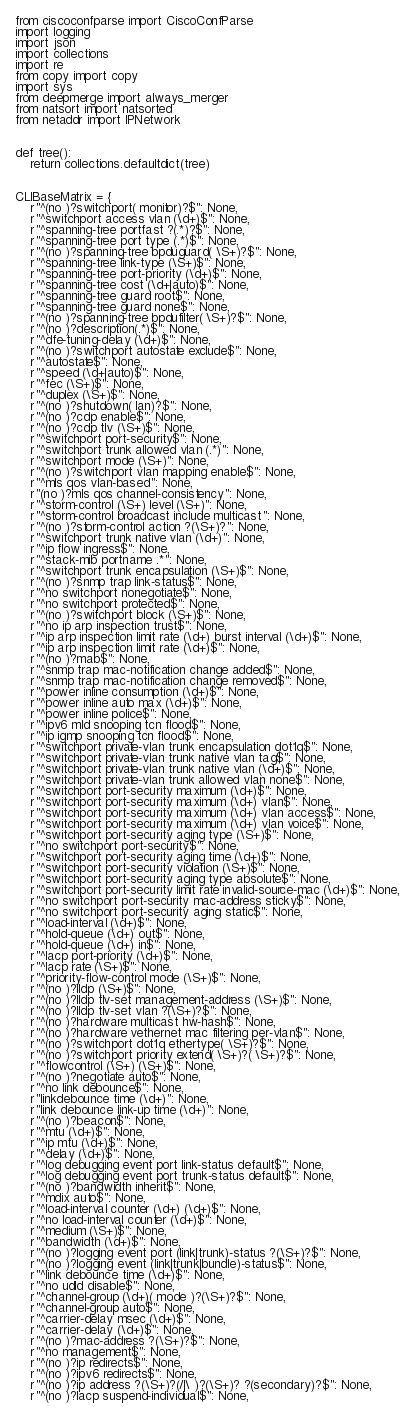Convert code to text. <code><loc_0><loc_0><loc_500><loc_500><_Python_>from ciscoconfparse import CiscoConfParse
import logging
import json
import collections
import re
from copy import copy
import sys
from deepmerge import always_merger
from natsort import natsorted
from netaddr import IPNetwork


def tree():
    return collections.defaultdict(tree)


CLIBaseMatrix = {
    r"^(no )?switchport( monitor)?$": None,
    r"^switchport access vlan (\d+)$": None,
    r"^spanning-tree portfast ?(.*)?$": None,
    r"^spanning-tree port type (.*)$": None,
    r"^(no )?spanning-tree bpduguard( \S+)?$": None,
    r"^spanning-tree link-type (\S+)$": None,
    r"^spanning-tree port-priority (\d+)$": None,
    r"^spanning-tree cost (\d+|auto)$": None,
    r"^spanning-tree guard root$": None,
    r"^spanning-tree guard none$": None,
    r"^(no )?spanning-tree bpdufilter( \S+)?$": None,
    r"^(no )?description(.*)$": None,
    r"^dfe-tuning-delay (\d+)$": None,
    r"^(no )?switchport autostate exclude$": None,
    r"^autostate$": None,
    r"^speed (\d+|auto)$": None,
    r"^fec (\S+)$": None,
    r"^duplex (\S+)$": None,
    r"^(no )?shutdown( lan)?$": None,
    r"^(no )?cdp enable$": None,
    r"^(no )?cdp tlv (\S+)$": None,
    r"^switchport port-security$": None,
    r"^switchport trunk allowed vlan (.*)": None,
    r"^switchport mode (\S+)": None,
    r"^(no )?switchport vlan mapping enable$": None,
    r"^mls qos vlan-based": None,
    r"(no )?mls qos channel-consistency": None,
    r"^storm-control (\S+) level (\S+)": None,
    r"^storm-control broadcast include multicast": None,
    r"^(no )?storm-control action ?(\S+)?": None,
    r"^switchport trunk native vlan (\d+)": None,
    r"^ip flow ingress$": None,
    r"^stack-mib portname .*": None,
    r"^switchport trunk encapsulation (\S+)$": None,
    r"^(no )?snmp trap link-status$": None,
    r"^no switchport nonegotiate$": None,
    r"^no switchport protected$": None,
    r"^(no )?switchport block (\S+)$": None,
    r"^no ip arp inspection trust$": None,
    r"^ip arp inspection limit rate (\d+) burst interval (\d+)$": None,
    r"^ip arp inspection limit rate (\d+)$": None,
    r"^(no )?mab$": None,
    r"^snmp trap mac-notification change added$": None,
    r"^snmp trap mac-notification change removed$": None,
    r"^power inline consumption (\d+)$": None,
    r"^power inline auto max (\d+)$": None,
    r"^power inline police$": None,
    r"^ipv6 mld snooping tcn flood$": None,
    r"^ip igmp snooping tcn flood$": None,
    r"^switchport private-vlan trunk encapsulation dot1q$": None,
    r"^switchport private-vlan trunk native vlan tag$": None,
    r"^switchport private-vlan trunk native vlan (\d+)$": None,
    r"^switchport private-vlan trunk allowed vlan none$": None,
    r"^switchport port-security maximum (\d+)$": None,
    r"^switchport port-security maximum (\d+) vlan$": None,
    r"^switchport port-security maximum (\d+) vlan access$": None,
    r"^switchport port-security maximum (\d+) vlan voice$": None,
    r"^switchport port-security aging type (\S+)$": None,
    r"^no switchport port-security$": None,
    r"^switchport port-security aging time (\d+)$": None,
    r"^switchport port-security violation (\S+)$": None,
    r"^switchport port-security aging type absolute$": None,
    r"^switchport port-security limit rate invalid-source-mac (\d+)$": None,
    r"^no switchport port-security mac-address sticky$": None,
    r"^no switchport port-security aging static$": None,
    r"^load-interval (\d+)$": None,
    r"^hold-queue (\d+) out$": None,
    r"^hold-queue (\d+) in$": None,
    r"^lacp port-priority (\d+)$": None,
    r"^lacp rate (\S+)$": None,
    r"^priority-flow-control mode (\S+)$": None,
    r"^(no )?lldp (\S+)$": None,
    r"^(no )?lldp tlv-set management-address (\S+)$": None,
    r"^(no )?lldp tlv-set vlan ?(\S+)?$": None,
    r"^(no )?hardware multicast hw-hash$": None,
    r"^(no )?hardware vethernet mac filtering per-vlan$": None,
    r"^(no )?switchport dot1q ethertype( \S+)?$": None,
    r"^(no )?switchport priority extend( \S+)?( \S+)?$": None,
    r"^flowcontrol (\S+) (\S+)$": None,
    r"^(no )?negotiate auto$": None,
    r"^no link debounce$": None,
    r"linkdebounce time (\d+)": None,
    r"link debounce link-up time (\d+)": None,
    r"^(no )?beacon$": None,
    r"^mtu (\d+)$": None,
    r"^ip mtu (\d+)$": None,
    r"^delay (\d+)$": None,
    r"^log debugging event port link-status default$": None,
    r"^log debugging event port trunk-status default$": None,
    r"^(no )?bandwidth inherit$": None,
    r"^mdix auto$": None,
    r"^load-interval counter (\d+) (\d+)$": None,
    r"^no load-interval counter (\d+)$": None,
    r"^medium (\S+)$": None,
    r"^bandwidth (\d+)$": None,
    r"^(no )?logging event port (link|trunk)-status ?(\S+)?$": None,
    r"^(no )?logging event (link|trunk|bundle)-status$": None,
    r"^link debounce time (\d+)$": None,
    r"^no udld disable$": None,
    r"^channel-group (\d+)( mode )?(\S+)?$": None,
    r"^channel-group auto$": None,
    r"^carrier-delay msec (\d+)$": None,
    r"^carrier-delay (\d+)$": None,
    r"^(no )?mac-address ?(\S+)?$": None,
    r"^no management$": None,
    r"^(no )?ip redirects$": None,
    r"^(no )?ipv6 redirects$": None,
    r"^(no )?ip address ?(\S+)?(/|\ )?(\S+)? ?(secondary)?$": None,
    r"^(no )?lacp suspend-individual$": None,</code> 